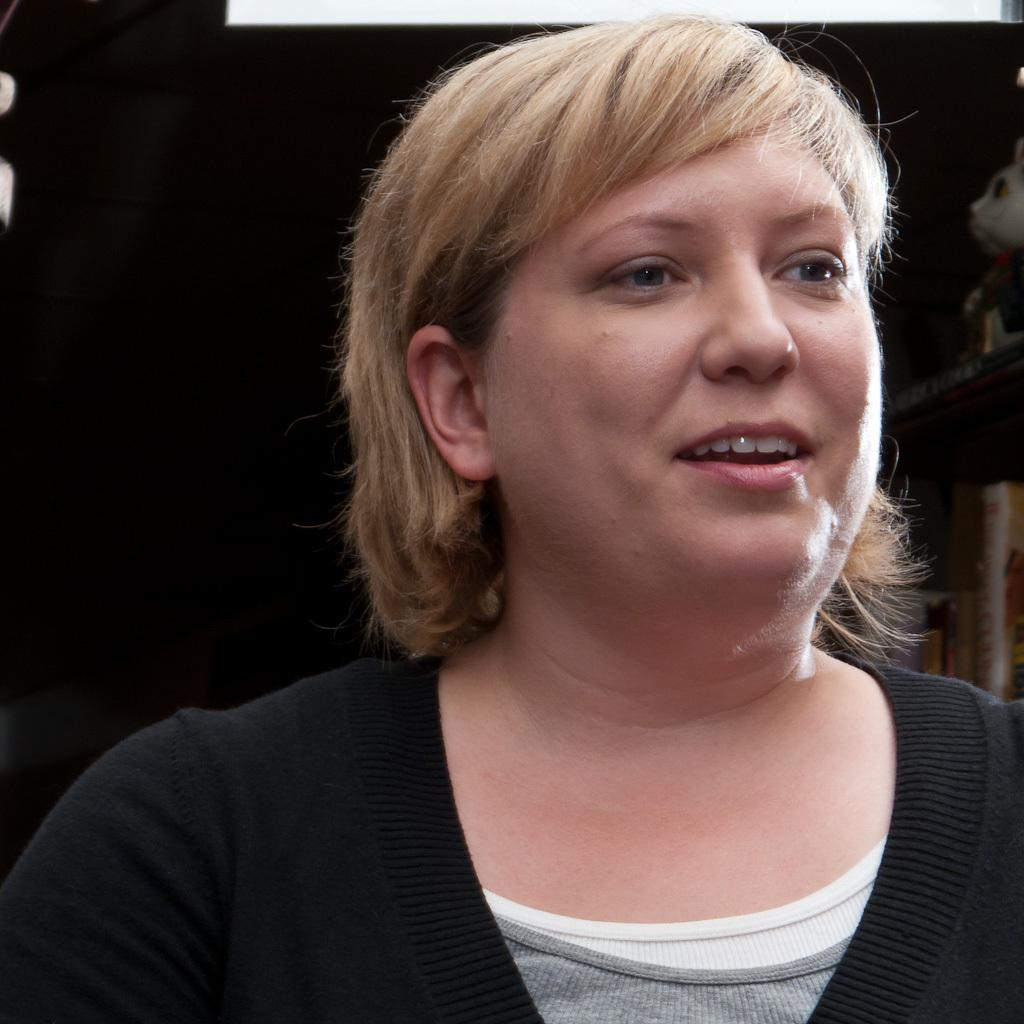What is the main subject of the image? There is a picture of a woman in the image. What type of peace can be seen in the wilderness in the image? There is no wilderness or peace present in the image; it only features a picture of a woman. 